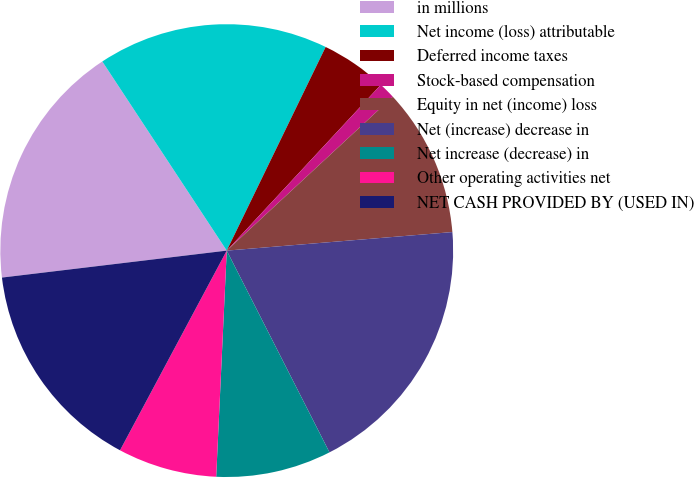Convert chart. <chart><loc_0><loc_0><loc_500><loc_500><pie_chart><fcel>in millions<fcel>Net income (loss) attributable<fcel>Deferred income taxes<fcel>Stock-based compensation<fcel>Equity in net (income) loss<fcel>Net (increase) decrease in<fcel>Net increase (decrease) in<fcel>Other operating activities net<fcel>NET CASH PROVIDED BY (USED IN)<nl><fcel>17.64%<fcel>16.46%<fcel>4.72%<fcel>1.19%<fcel>10.59%<fcel>18.81%<fcel>8.24%<fcel>7.07%<fcel>15.29%<nl></chart> 